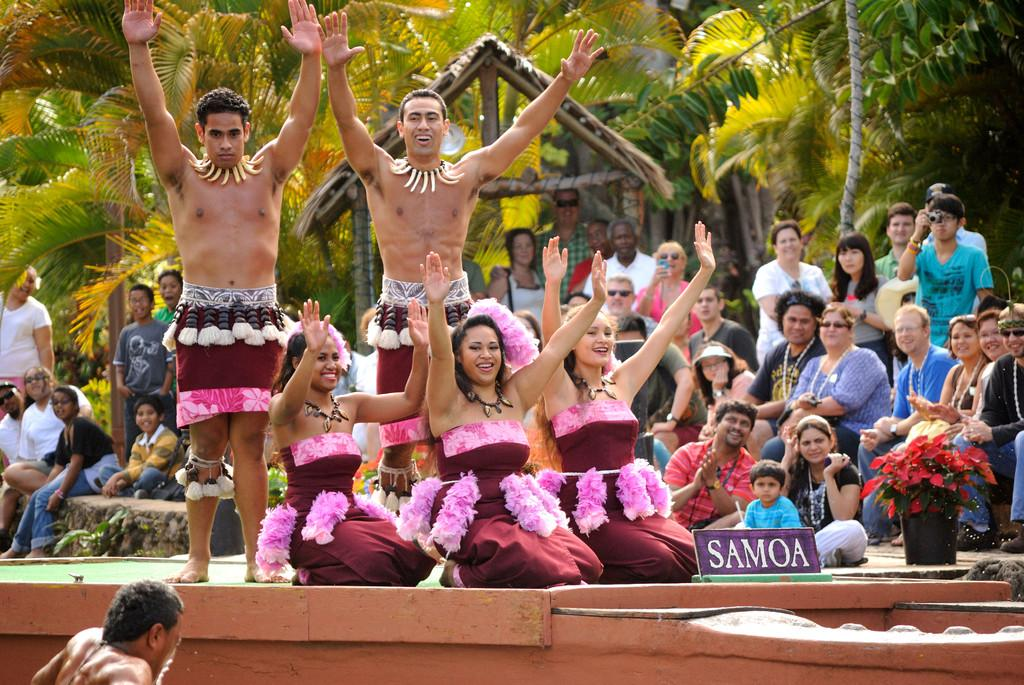How many people are in the image? There are people in the image, but the exact number is not specified. Where are some of the people located in the image? Some people are on a stage in the image. What type of natural elements can be seen in the image? There are trees in the image. What type of structure is present in the image? There is a shed in the image. What type of plant is in a pot in the image? There are plants in a pot in the image. What type of signage is present in the image? There is a board with text in the image. What type of game is being played on the stage in the image? There is no game being played on the stage in the image; it is not mentioned in the facts. How much dust can be seen on the shed in the image? There is no mention of dust in the image, so it cannot be determined. 